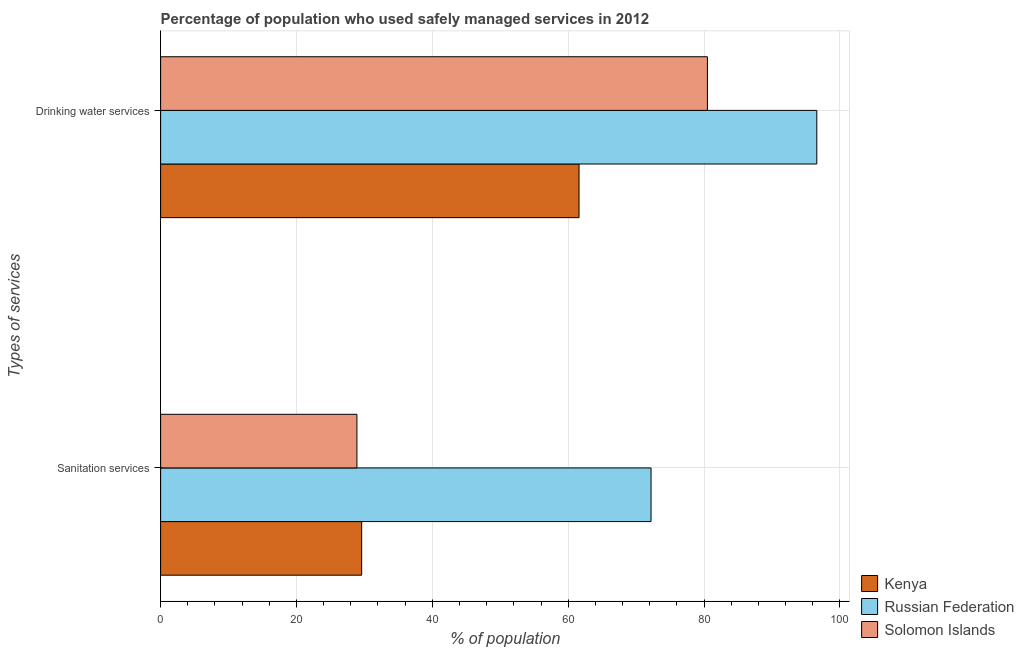How many different coloured bars are there?
Your answer should be compact. 3. Are the number of bars per tick equal to the number of legend labels?
Your response must be concise. Yes. Are the number of bars on each tick of the Y-axis equal?
Keep it short and to the point. Yes. What is the label of the 1st group of bars from the top?
Provide a succinct answer. Drinking water services. What is the percentage of population who used drinking water services in Solomon Islands?
Ensure brevity in your answer.  80.5. Across all countries, what is the maximum percentage of population who used drinking water services?
Give a very brief answer. 96.6. Across all countries, what is the minimum percentage of population who used sanitation services?
Your answer should be compact. 28.9. In which country was the percentage of population who used sanitation services maximum?
Ensure brevity in your answer.  Russian Federation. In which country was the percentage of population who used drinking water services minimum?
Provide a succinct answer. Kenya. What is the total percentage of population who used drinking water services in the graph?
Provide a succinct answer. 238.7. What is the difference between the percentage of population who used sanitation services in Kenya and that in Solomon Islands?
Provide a short and direct response. 0.7. What is the difference between the percentage of population who used sanitation services in Russian Federation and the percentage of population who used drinking water services in Solomon Islands?
Your answer should be very brief. -8.3. What is the average percentage of population who used drinking water services per country?
Make the answer very short. 79.57. What is the difference between the percentage of population who used sanitation services and percentage of population who used drinking water services in Kenya?
Make the answer very short. -32. In how many countries, is the percentage of population who used sanitation services greater than 96 %?
Give a very brief answer. 0. What is the ratio of the percentage of population who used sanitation services in Russian Federation to that in Solomon Islands?
Make the answer very short. 2.5. Is the percentage of population who used sanitation services in Kenya less than that in Russian Federation?
Provide a short and direct response. Yes. In how many countries, is the percentage of population who used sanitation services greater than the average percentage of population who used sanitation services taken over all countries?
Make the answer very short. 1. What does the 3rd bar from the top in Drinking water services represents?
Your answer should be very brief. Kenya. What does the 1st bar from the bottom in Drinking water services represents?
Offer a terse response. Kenya. How many countries are there in the graph?
Your response must be concise. 3. What is the difference between two consecutive major ticks on the X-axis?
Make the answer very short. 20. Are the values on the major ticks of X-axis written in scientific E-notation?
Keep it short and to the point. No. Does the graph contain any zero values?
Your response must be concise. No. How many legend labels are there?
Give a very brief answer. 3. What is the title of the graph?
Your answer should be very brief. Percentage of population who used safely managed services in 2012. Does "Canada" appear as one of the legend labels in the graph?
Your response must be concise. No. What is the label or title of the X-axis?
Ensure brevity in your answer.  % of population. What is the label or title of the Y-axis?
Ensure brevity in your answer.  Types of services. What is the % of population of Kenya in Sanitation services?
Offer a very short reply. 29.6. What is the % of population in Russian Federation in Sanitation services?
Provide a short and direct response. 72.2. What is the % of population in Solomon Islands in Sanitation services?
Your response must be concise. 28.9. What is the % of population in Kenya in Drinking water services?
Make the answer very short. 61.6. What is the % of population of Russian Federation in Drinking water services?
Provide a short and direct response. 96.6. What is the % of population of Solomon Islands in Drinking water services?
Offer a terse response. 80.5. Across all Types of services, what is the maximum % of population in Kenya?
Provide a succinct answer. 61.6. Across all Types of services, what is the maximum % of population of Russian Federation?
Ensure brevity in your answer.  96.6. Across all Types of services, what is the maximum % of population of Solomon Islands?
Offer a very short reply. 80.5. Across all Types of services, what is the minimum % of population in Kenya?
Offer a very short reply. 29.6. Across all Types of services, what is the minimum % of population of Russian Federation?
Offer a terse response. 72.2. Across all Types of services, what is the minimum % of population in Solomon Islands?
Provide a succinct answer. 28.9. What is the total % of population in Kenya in the graph?
Your response must be concise. 91.2. What is the total % of population of Russian Federation in the graph?
Offer a very short reply. 168.8. What is the total % of population in Solomon Islands in the graph?
Your response must be concise. 109.4. What is the difference between the % of population in Kenya in Sanitation services and that in Drinking water services?
Your answer should be compact. -32. What is the difference between the % of population in Russian Federation in Sanitation services and that in Drinking water services?
Offer a very short reply. -24.4. What is the difference between the % of population in Solomon Islands in Sanitation services and that in Drinking water services?
Ensure brevity in your answer.  -51.6. What is the difference between the % of population in Kenya in Sanitation services and the % of population in Russian Federation in Drinking water services?
Ensure brevity in your answer.  -67. What is the difference between the % of population in Kenya in Sanitation services and the % of population in Solomon Islands in Drinking water services?
Make the answer very short. -50.9. What is the average % of population of Kenya per Types of services?
Offer a very short reply. 45.6. What is the average % of population of Russian Federation per Types of services?
Provide a succinct answer. 84.4. What is the average % of population of Solomon Islands per Types of services?
Keep it short and to the point. 54.7. What is the difference between the % of population of Kenya and % of population of Russian Federation in Sanitation services?
Your answer should be compact. -42.6. What is the difference between the % of population in Kenya and % of population in Solomon Islands in Sanitation services?
Offer a very short reply. 0.7. What is the difference between the % of population of Russian Federation and % of population of Solomon Islands in Sanitation services?
Provide a succinct answer. 43.3. What is the difference between the % of population in Kenya and % of population in Russian Federation in Drinking water services?
Your response must be concise. -35. What is the difference between the % of population of Kenya and % of population of Solomon Islands in Drinking water services?
Ensure brevity in your answer.  -18.9. What is the difference between the % of population in Russian Federation and % of population in Solomon Islands in Drinking water services?
Your response must be concise. 16.1. What is the ratio of the % of population of Kenya in Sanitation services to that in Drinking water services?
Ensure brevity in your answer.  0.48. What is the ratio of the % of population of Russian Federation in Sanitation services to that in Drinking water services?
Provide a short and direct response. 0.75. What is the ratio of the % of population in Solomon Islands in Sanitation services to that in Drinking water services?
Your response must be concise. 0.36. What is the difference between the highest and the second highest % of population in Kenya?
Your answer should be very brief. 32. What is the difference between the highest and the second highest % of population of Russian Federation?
Make the answer very short. 24.4. What is the difference between the highest and the second highest % of population in Solomon Islands?
Your answer should be compact. 51.6. What is the difference between the highest and the lowest % of population of Russian Federation?
Your response must be concise. 24.4. What is the difference between the highest and the lowest % of population in Solomon Islands?
Provide a short and direct response. 51.6. 